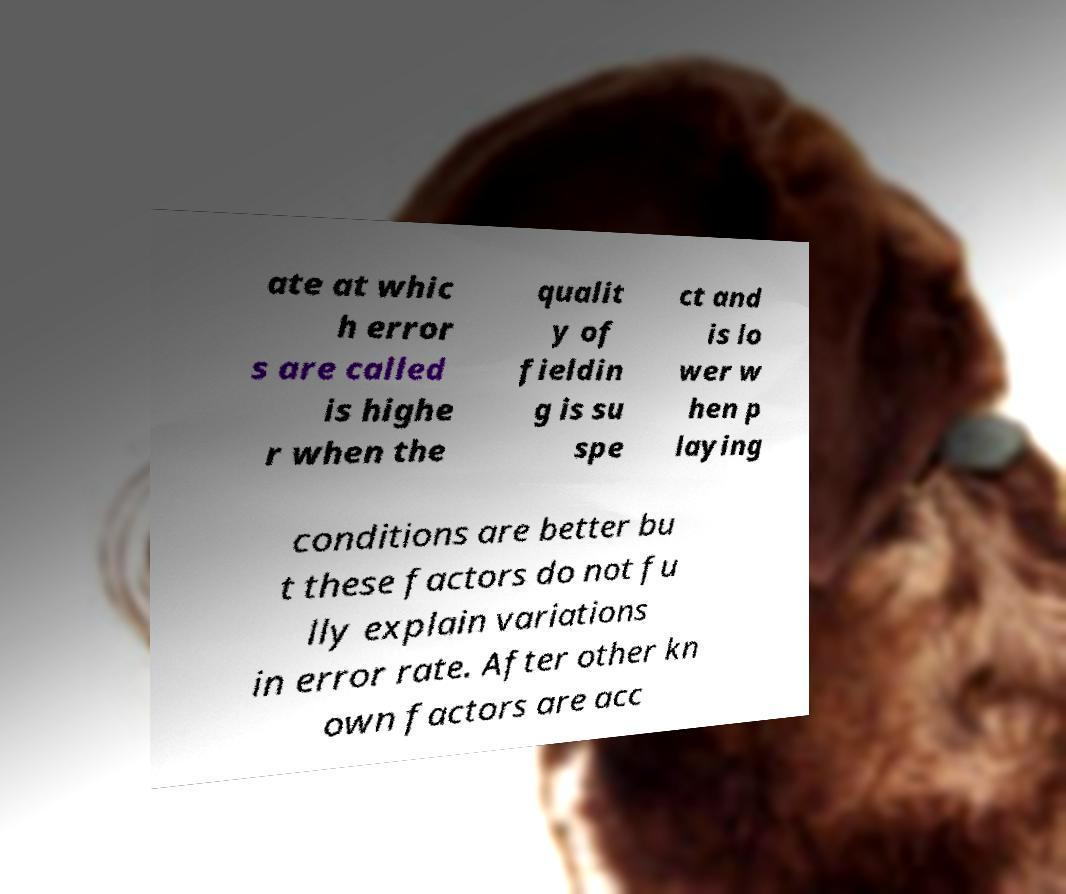Can you accurately transcribe the text from the provided image for me? ate at whic h error s are called is highe r when the qualit y of fieldin g is su spe ct and is lo wer w hen p laying conditions are better bu t these factors do not fu lly explain variations in error rate. After other kn own factors are acc 